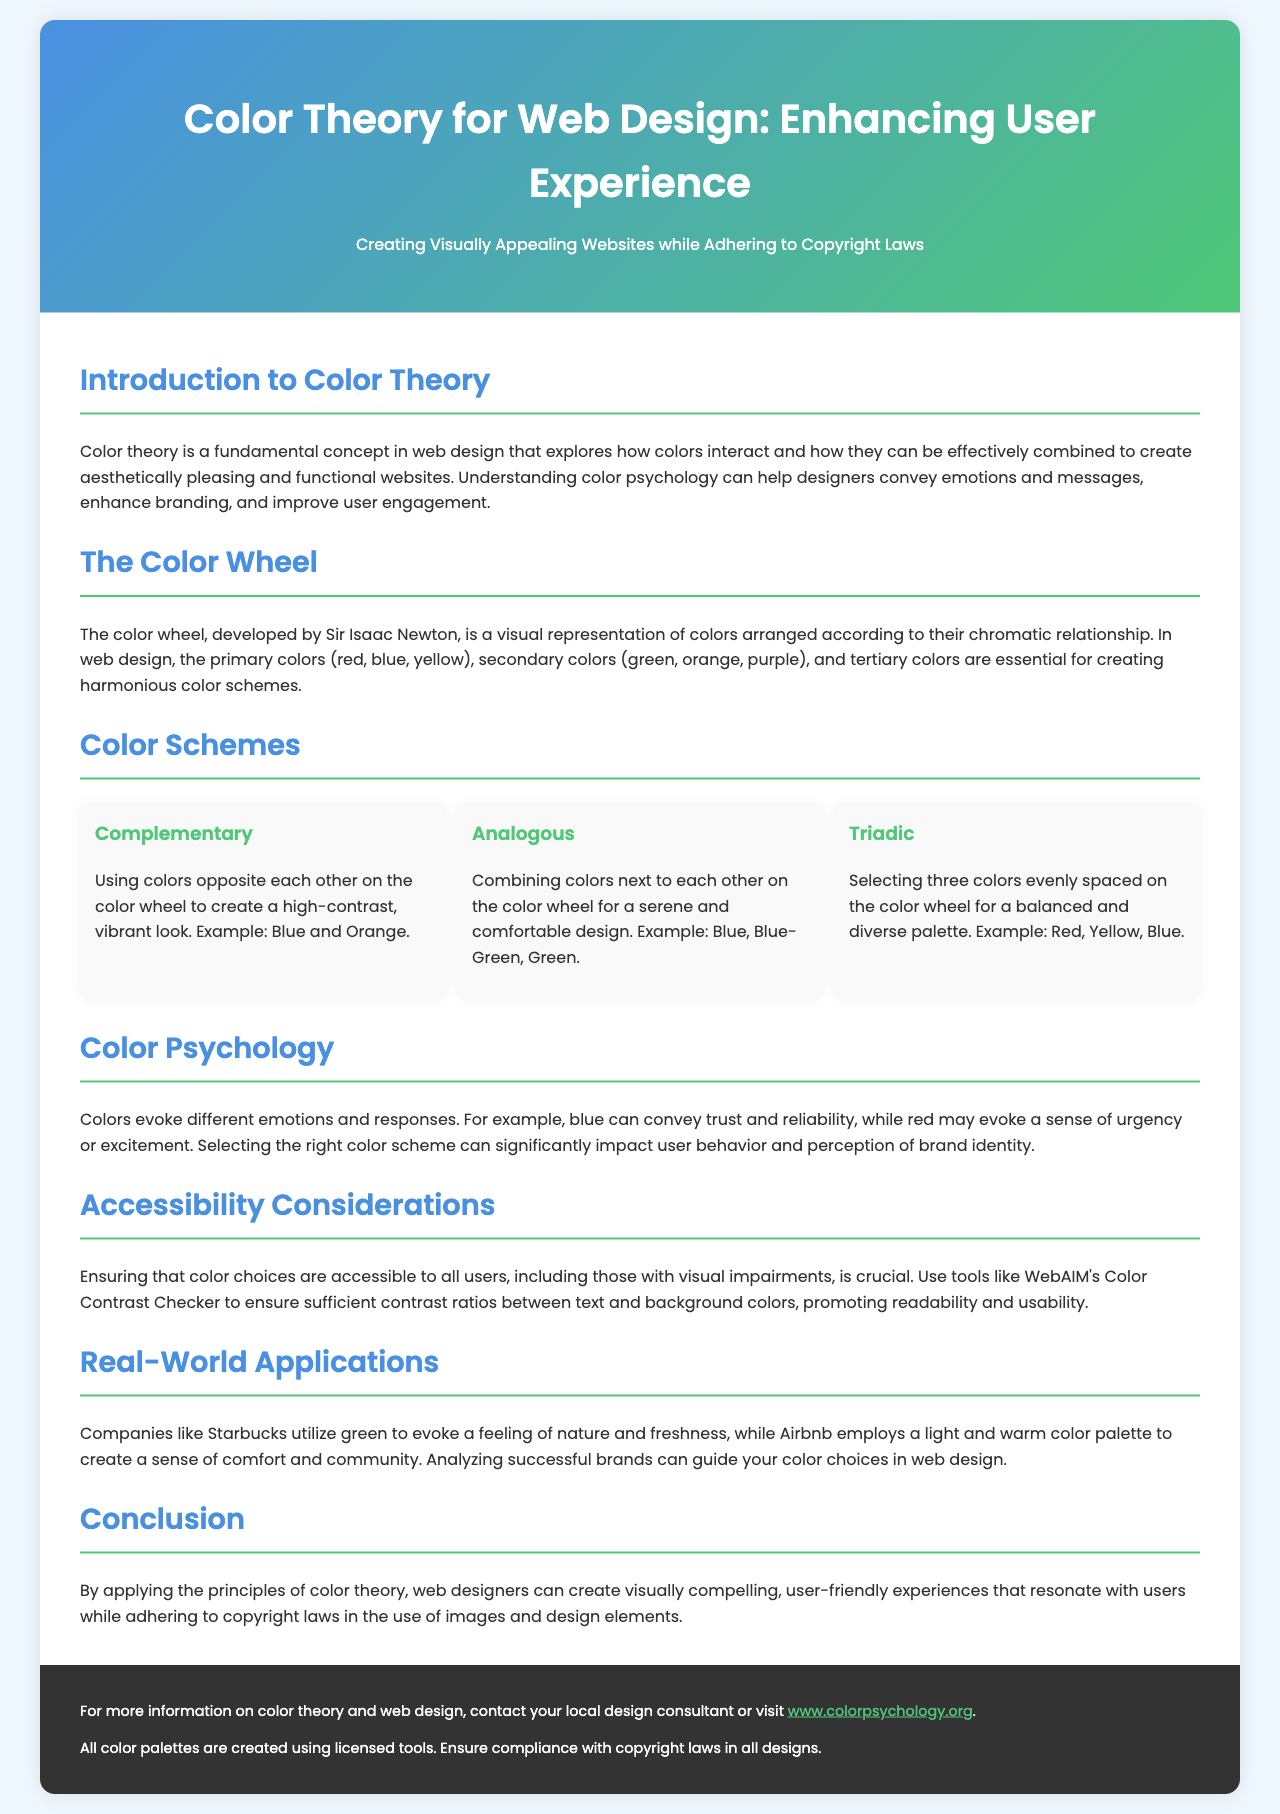What is the main purpose of the brochure? The brochure aims to educate readers about color theory in web design and its impact on user experience while adhering to copyright laws.
Answer: Educate readers about color theory in web design Who developed the color wheel? The document states that the color wheel was developed by Sir Isaac Newton.
Answer: Sir Isaac Newton What color scheme uses colors opposite each other on the color wheel? The document describes the complementary color scheme, which uses opposite colors for a vibrant look.
Answer: Complementary What are the examples of an analogous color scheme? The text provides blue, blue-green, and green as examples of an analogous color scheme.
Answer: Blue, Blue-Green, Green What emotional response does the color blue evoke? The document suggests that blue can convey trust and reliability, impacting user perception.
Answer: Trust and reliability What is a key accessibility consideration mentioned? It emphasizes using tools like WebAIM's Color Contrast Checker for ensuring color contrast is sufficient for readability.
Answer: Color Contrast Checker Which company is mentioned as using the color green effectively? The brochure mentions Starbucks as an example of a company that evokes feelings of nature and freshness with green.
Answer: Starbucks What is emphasized about copyright laws in the conclusion? The conclusion highlights the importance of adherence to copyright laws in all designs used.
Answer: Adherence to copyright laws 